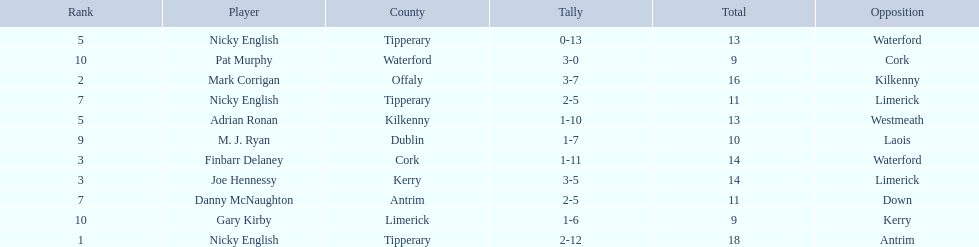Who was the top ranked player in a single game? Nicky English. 